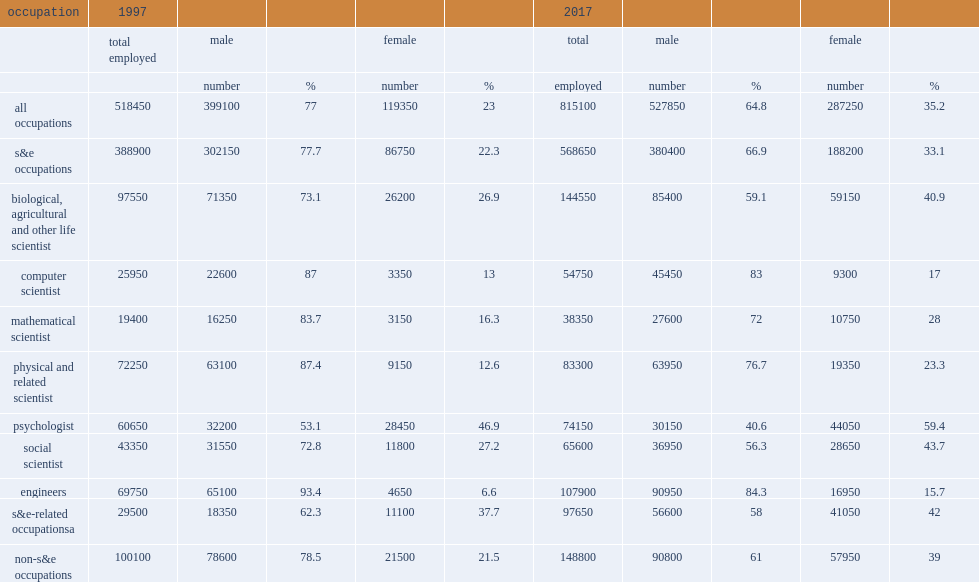What was the number of u.s.-trained female seh doctorate holders residing and working in the united states in 1997? 119350.0. What was the number of u.s.-trained female seh doctorate holders residing and working in the united states in 2017? 287250.0. By 2017, which gender's number of psychologists was higher, female or male? Female. 